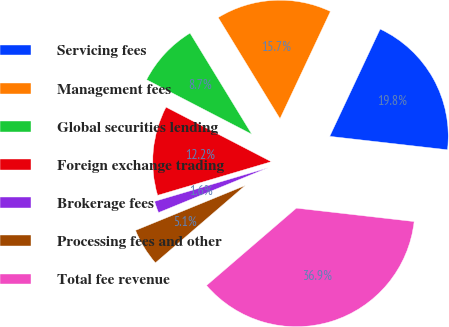<chart> <loc_0><loc_0><loc_500><loc_500><pie_chart><fcel>Servicing fees<fcel>Management fees<fcel>Global securities lending<fcel>Foreign exchange trading<fcel>Brokerage fees<fcel>Processing fees and other<fcel>Total fee revenue<nl><fcel>19.81%<fcel>15.72%<fcel>8.66%<fcel>12.19%<fcel>1.6%<fcel>5.13%<fcel>36.88%<nl></chart> 